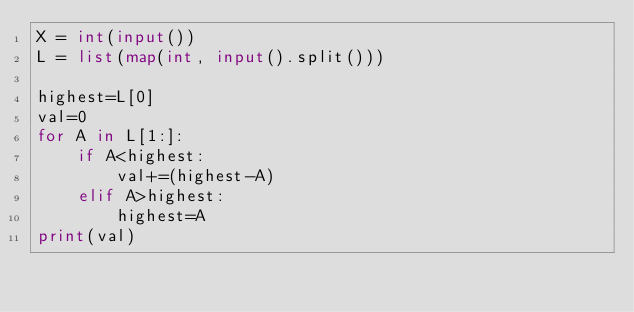<code> <loc_0><loc_0><loc_500><loc_500><_Python_>X = int(input())
L = list(map(int, input().split()))

highest=L[0]
val=0
for A in L[1:]:
    if A<highest:
        val+=(highest-A)
    elif A>highest:
        highest=A
print(val)
</code> 